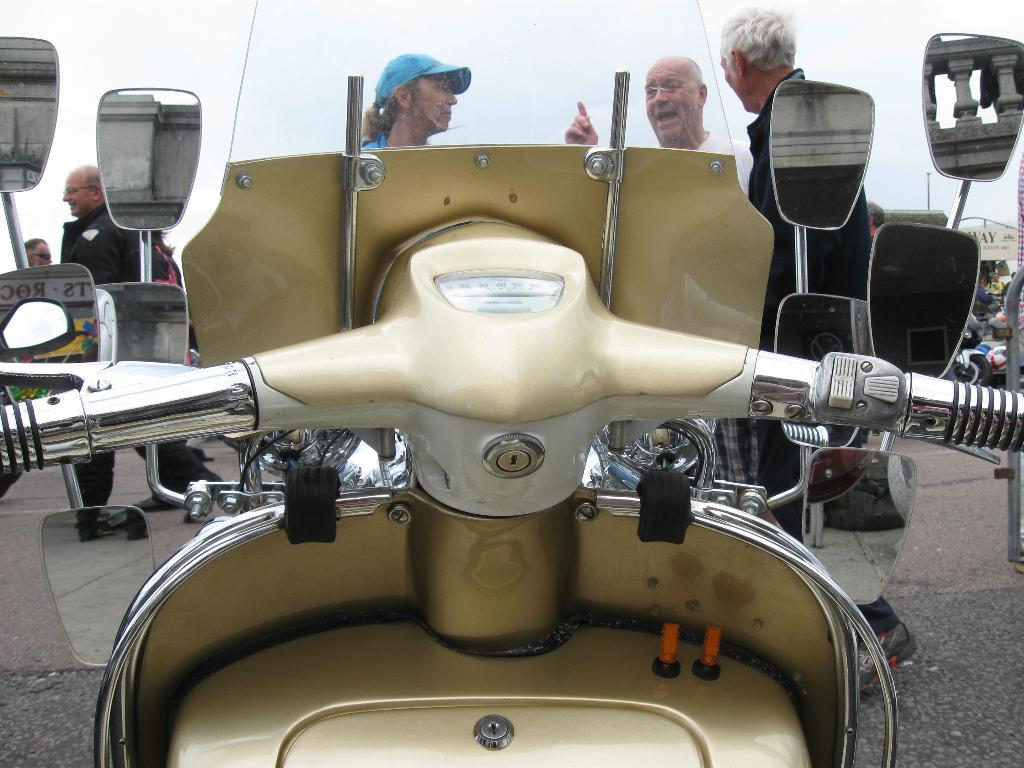What is the main object in the middle of the image? There is a scooter handle in the middle of the image. What feature is attached to the scooter handle? There are four mirrors attached to the scooter handle. How many people are in front of the scooter? There are three men in front of the scooter. What are the men doing in the image? The men are discussing with each other. What type of pan can be seen in the sky in the image? There is no pan visible in the sky in the image. Why are the men crying in the image? The men are not crying in the image; they are discussing with each other. 